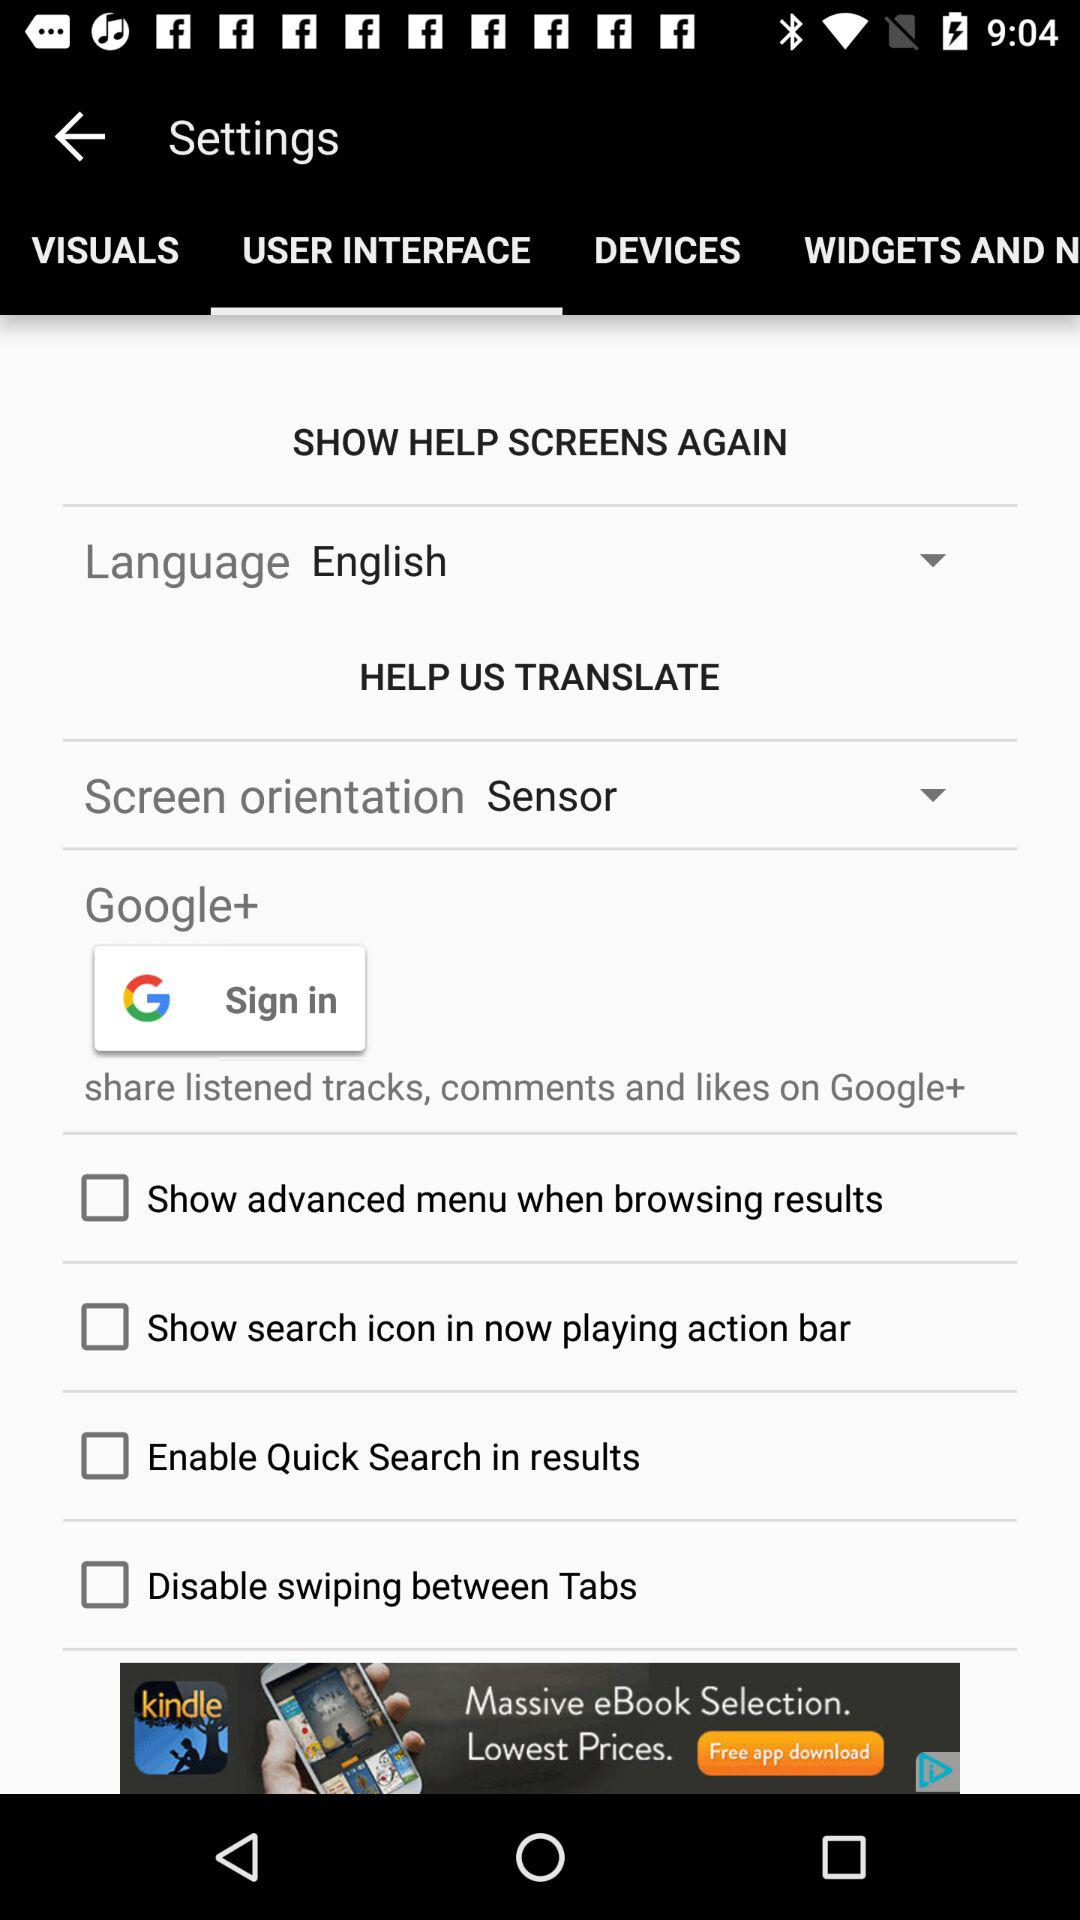Which option is selected in the "Screen orientation" setting? The selected option is "Sensor". 